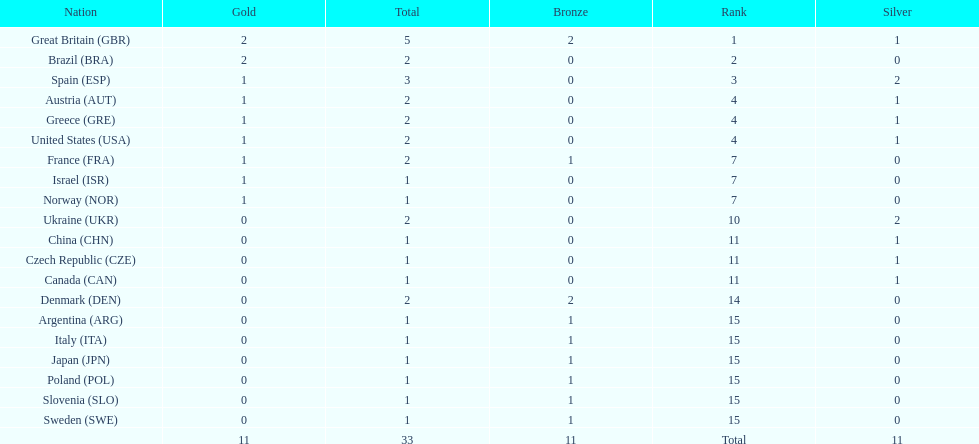How many countries won at least 1 gold and 1 silver medal? 5. 